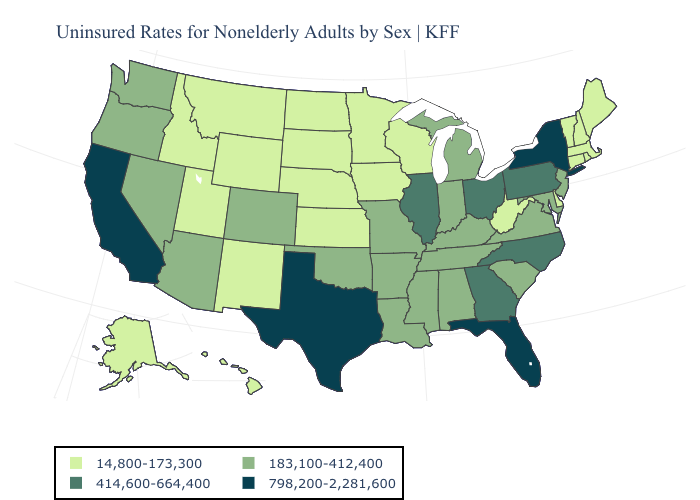Among the states that border Delaware , which have the highest value?
Concise answer only. Pennsylvania. Does the map have missing data?
Give a very brief answer. No. Does North Carolina have the same value as Minnesota?
Concise answer only. No. What is the highest value in the USA?
Short answer required. 798,200-2,281,600. What is the value of New Mexico?
Concise answer only. 14,800-173,300. What is the value of Nebraska?
Concise answer only. 14,800-173,300. Which states have the highest value in the USA?
Be succinct. California, Florida, New York, Texas. Does South Carolina have the lowest value in the USA?
Keep it brief. No. What is the highest value in states that border New York?
Short answer required. 414,600-664,400. Does Alaska have the highest value in the USA?
Give a very brief answer. No. Does New Hampshire have the highest value in the Northeast?
Give a very brief answer. No. Among the states that border Washington , which have the lowest value?
Write a very short answer. Idaho. 